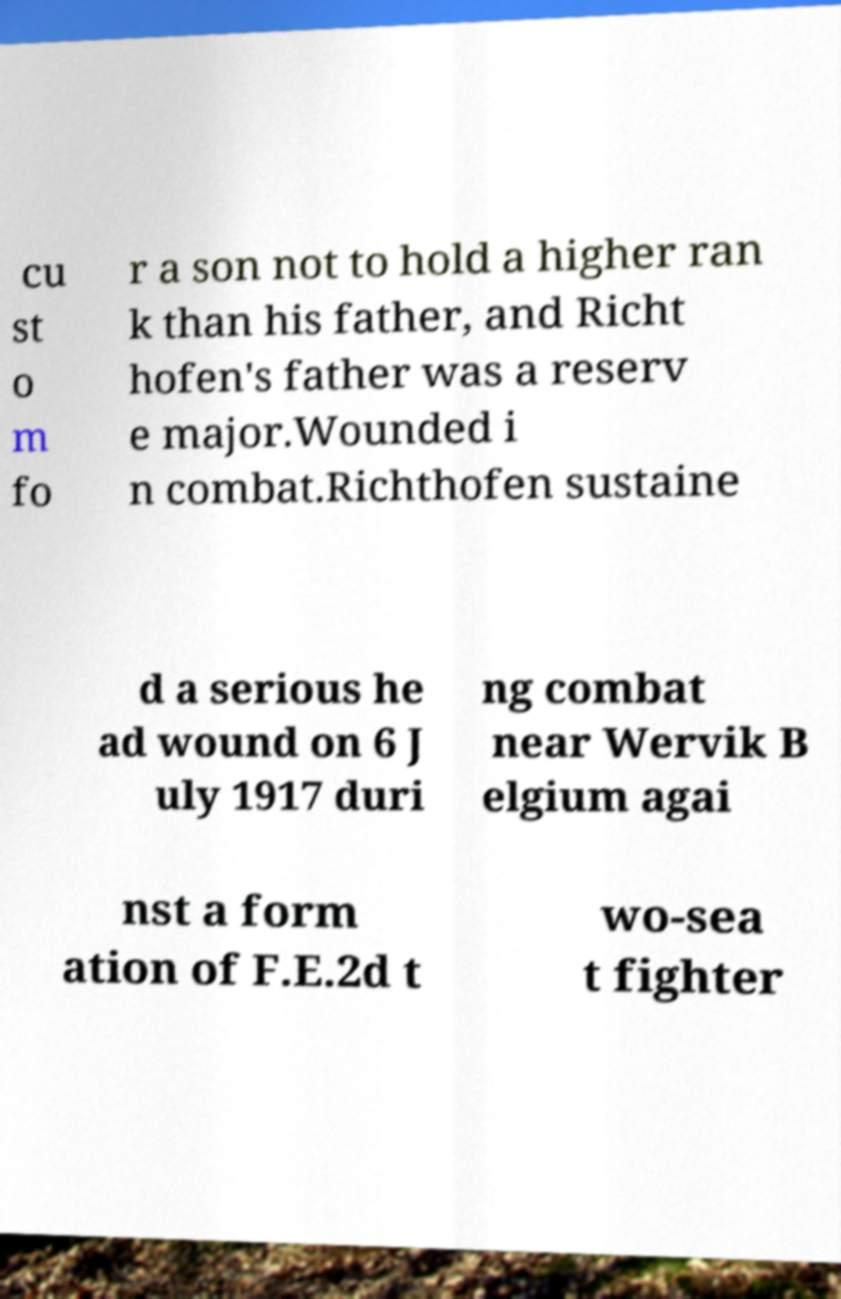For documentation purposes, I need the text within this image transcribed. Could you provide that? cu st o m fo r a son not to hold a higher ran k than his father, and Richt hofen's father was a reserv e major.Wounded i n combat.Richthofen sustaine d a serious he ad wound on 6 J uly 1917 duri ng combat near Wervik B elgium agai nst a form ation of F.E.2d t wo-sea t fighter 